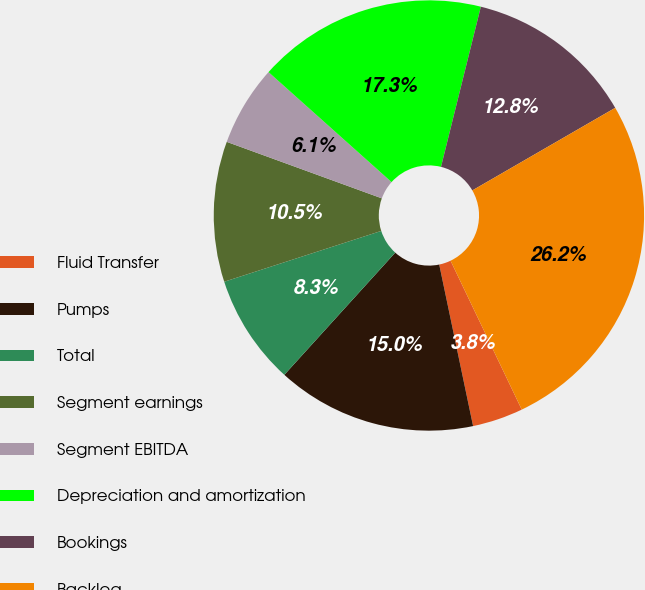Convert chart to OTSL. <chart><loc_0><loc_0><loc_500><loc_500><pie_chart><fcel>Fluid Transfer<fcel>Pumps<fcel>Total<fcel>Segment earnings<fcel>Segment EBITDA<fcel>Depreciation and amortization<fcel>Bookings<fcel>Backlog<nl><fcel>3.81%<fcel>15.02%<fcel>8.29%<fcel>10.54%<fcel>6.05%<fcel>17.27%<fcel>12.78%<fcel>26.24%<nl></chart> 